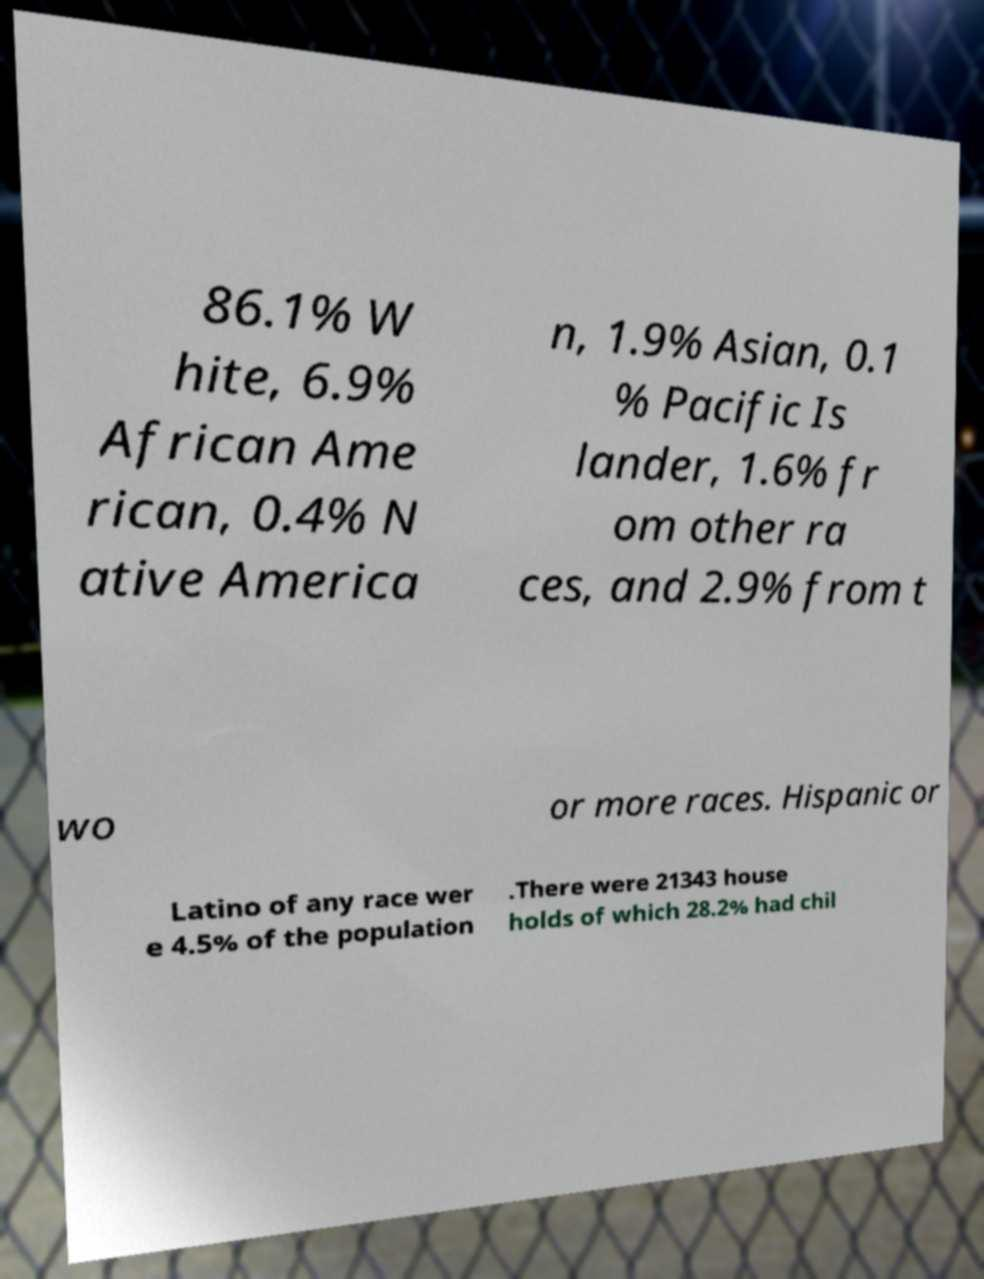Please read and relay the text visible in this image. What does it say? 86.1% W hite, 6.9% African Ame rican, 0.4% N ative America n, 1.9% Asian, 0.1 % Pacific Is lander, 1.6% fr om other ra ces, and 2.9% from t wo or more races. Hispanic or Latino of any race wer e 4.5% of the population .There were 21343 house holds of which 28.2% had chil 